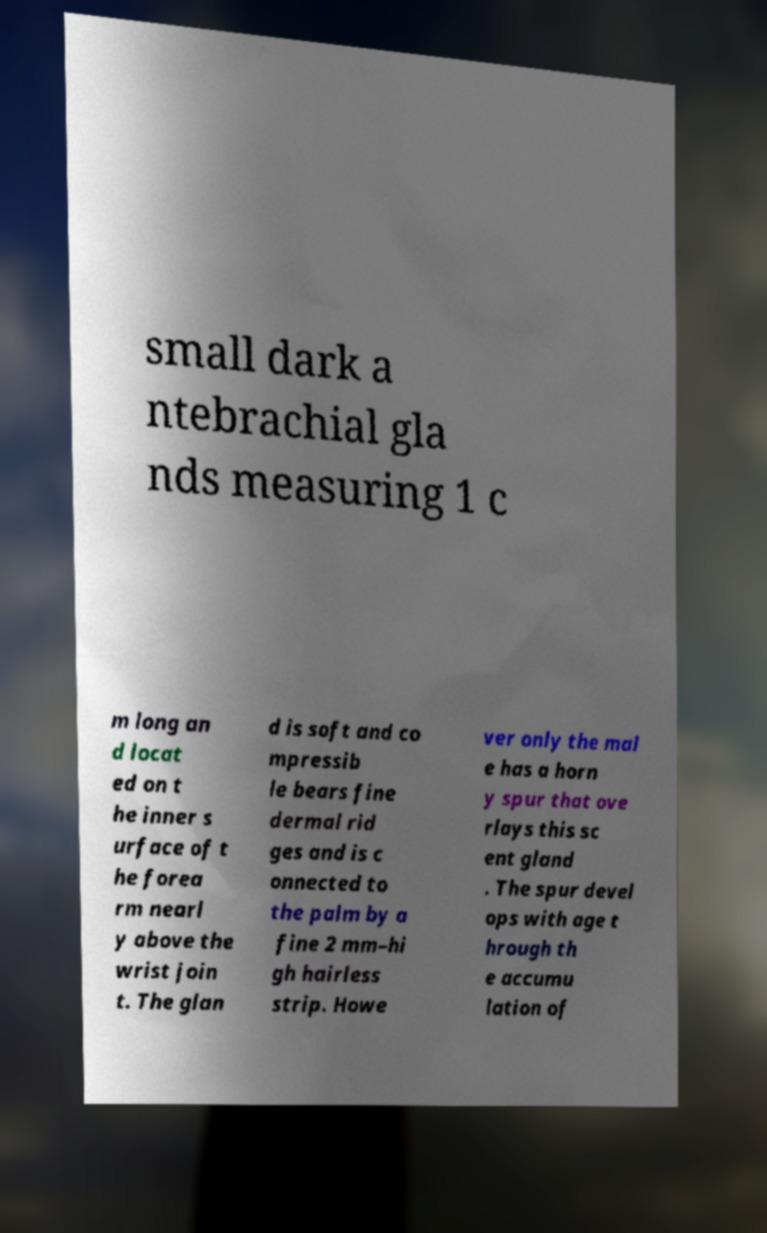What messages or text are displayed in this image? I need them in a readable, typed format. small dark a ntebrachial gla nds measuring 1 c m long an d locat ed on t he inner s urface of t he forea rm nearl y above the wrist join t. The glan d is soft and co mpressib le bears fine dermal rid ges and is c onnected to the palm by a fine 2 mm–hi gh hairless strip. Howe ver only the mal e has a horn y spur that ove rlays this sc ent gland . The spur devel ops with age t hrough th e accumu lation of 